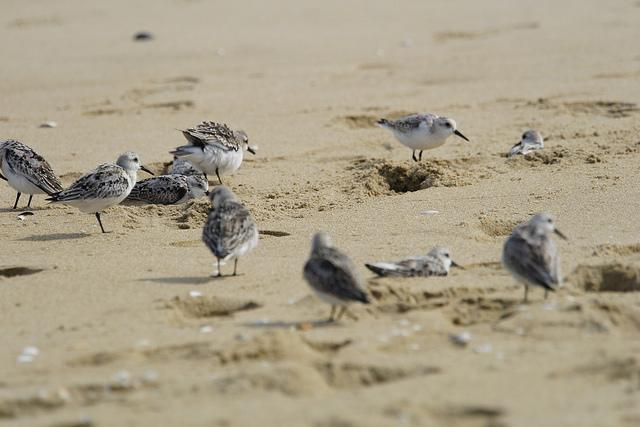What do people usually feed these animals?

Choices:
A) bread
B) dogs
C) cats
D) chili bread 